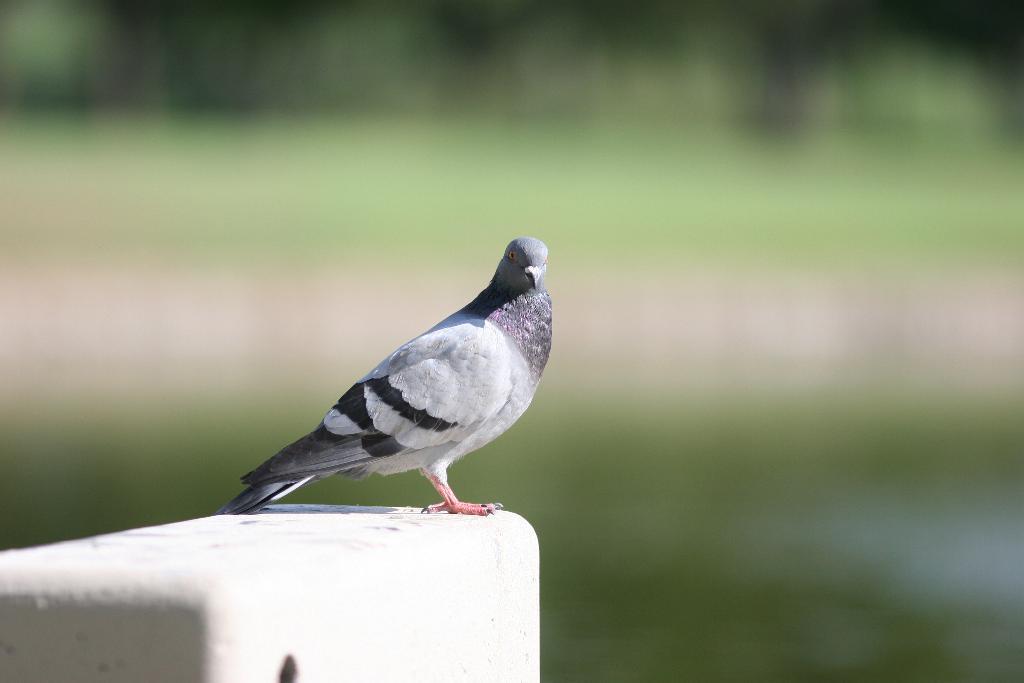How would you summarize this image in a sentence or two? In this image there is a pigeon on the wall. 